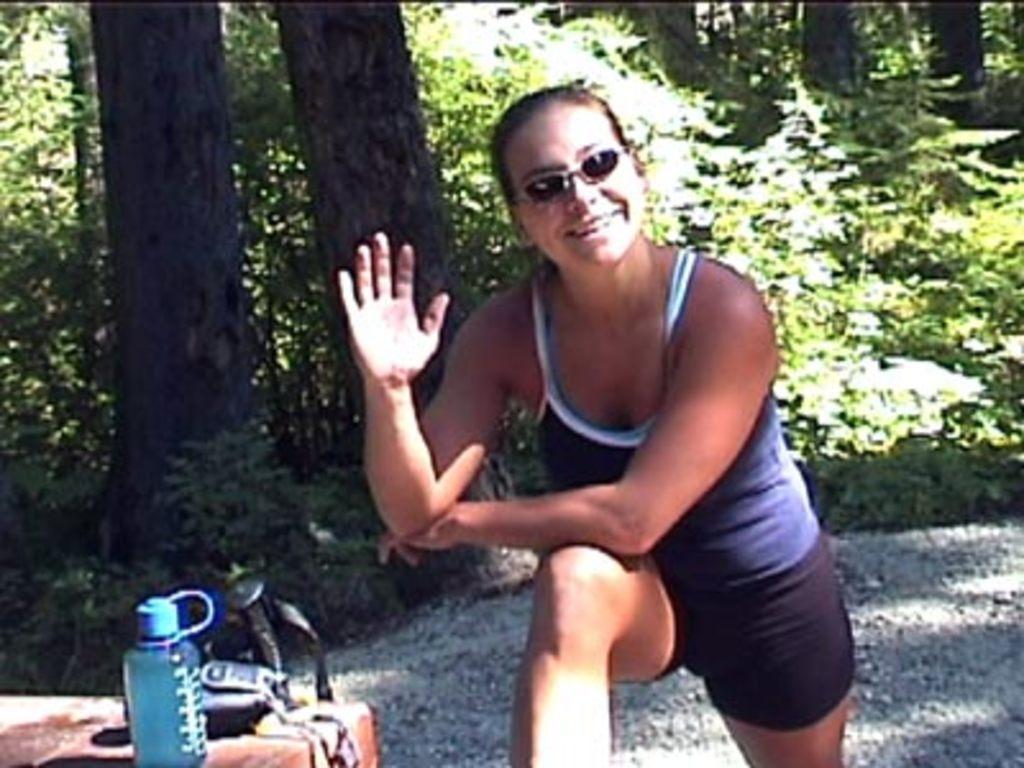How would you summarize this image in a sentence or two? In this image, we can see a woman is wearing goggles and smiling. Left side bottom, we can see bottle, few objects. Background we can see ground, few trees and plants. 